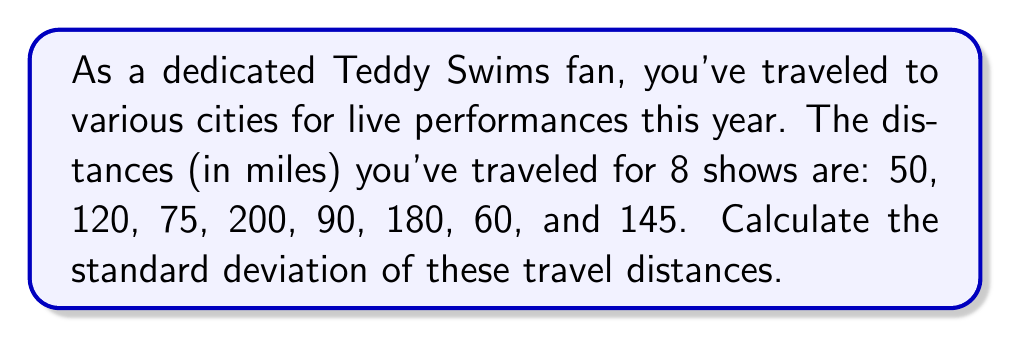What is the answer to this math problem? To calculate the standard deviation, we'll follow these steps:

1. Calculate the mean (average) distance:
   $$\bar{x} = \frac{\sum_{i=1}^{n} x_i}{n} = \frac{50 + 120 + 75 + 200 + 90 + 180 + 60 + 145}{8} = \frac{920}{8} = 115$$

2. Calculate the squared differences from the mean:
   $$(50 - 115)^2 = (-65)^2 = 4225$$
   $$(120 - 115)^2 = 5^2 = 25$$
   $$(75 - 115)^2 = (-40)^2 = 1600$$
   $$(200 - 115)^2 = 85^2 = 7225$$
   $$(90 - 115)^2 = (-25)^2 = 625$$
   $$(180 - 115)^2 = 65^2 = 4225$$
   $$(60 - 115)^2 = (-55)^2 = 3025$$
   $$(145 - 115)^2 = 30^2 = 900$$

3. Sum the squared differences:
   $$\sum_{i=1}^{n} (x_i - \bar{x})^2 = 4225 + 25 + 1600 + 7225 + 625 + 4225 + 3025 + 900 = 21850$$

4. Divide by (n-1) = 7 and take the square root:
   $$s = \sqrt{\frac{\sum_{i=1}^{n} (x_i - \bar{x})^2}{n-1}} = \sqrt{\frac{21850}{7}} \approx 55.90$$
Answer: $55.90$ miles 